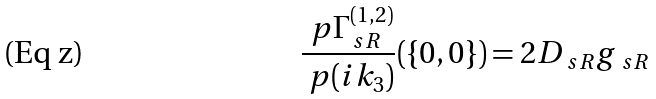Convert formula to latex. <formula><loc_0><loc_0><loc_500><loc_500>\frac { \ p \Gamma _ { \ s R } ^ { ( 1 , 2 ) } } { \ p ( i k _ { 3 } ) } ( \{ 0 , 0 \} ) = 2 D _ { \ s R } g _ { \ s R }</formula> 